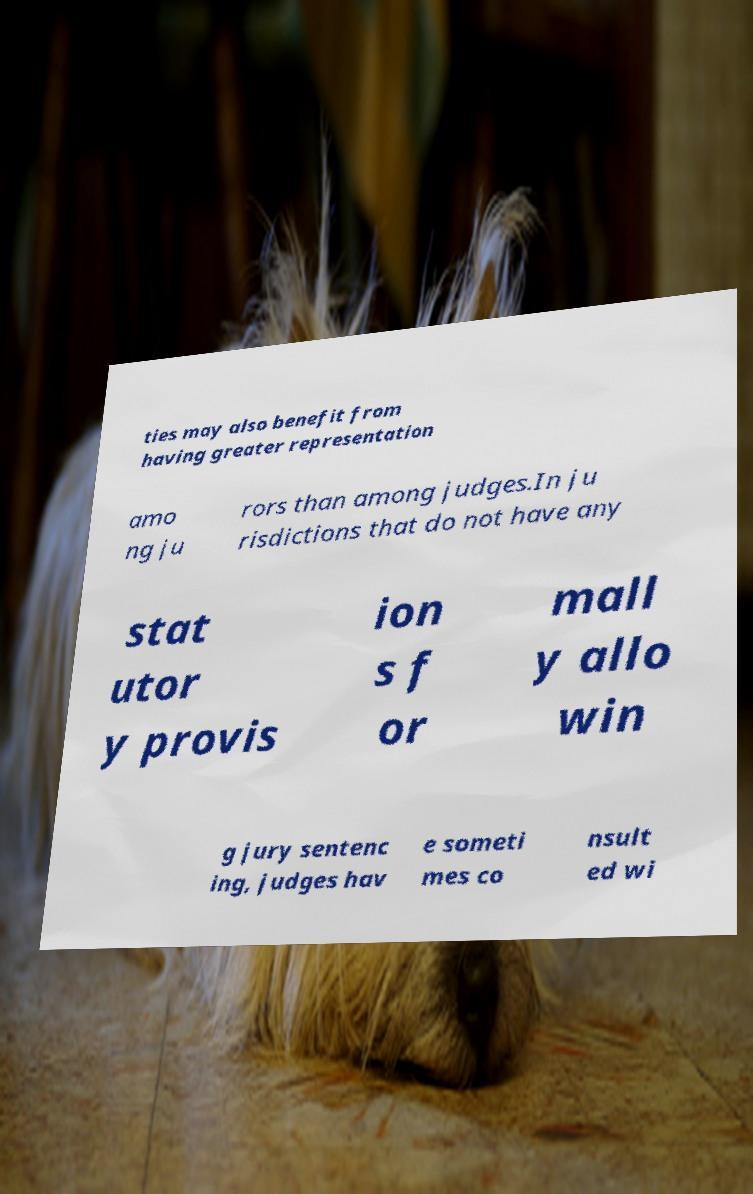Could you extract and type out the text from this image? ties may also benefit from having greater representation amo ng ju rors than among judges.In ju risdictions that do not have any stat utor y provis ion s f or mall y allo win g jury sentenc ing, judges hav e someti mes co nsult ed wi 